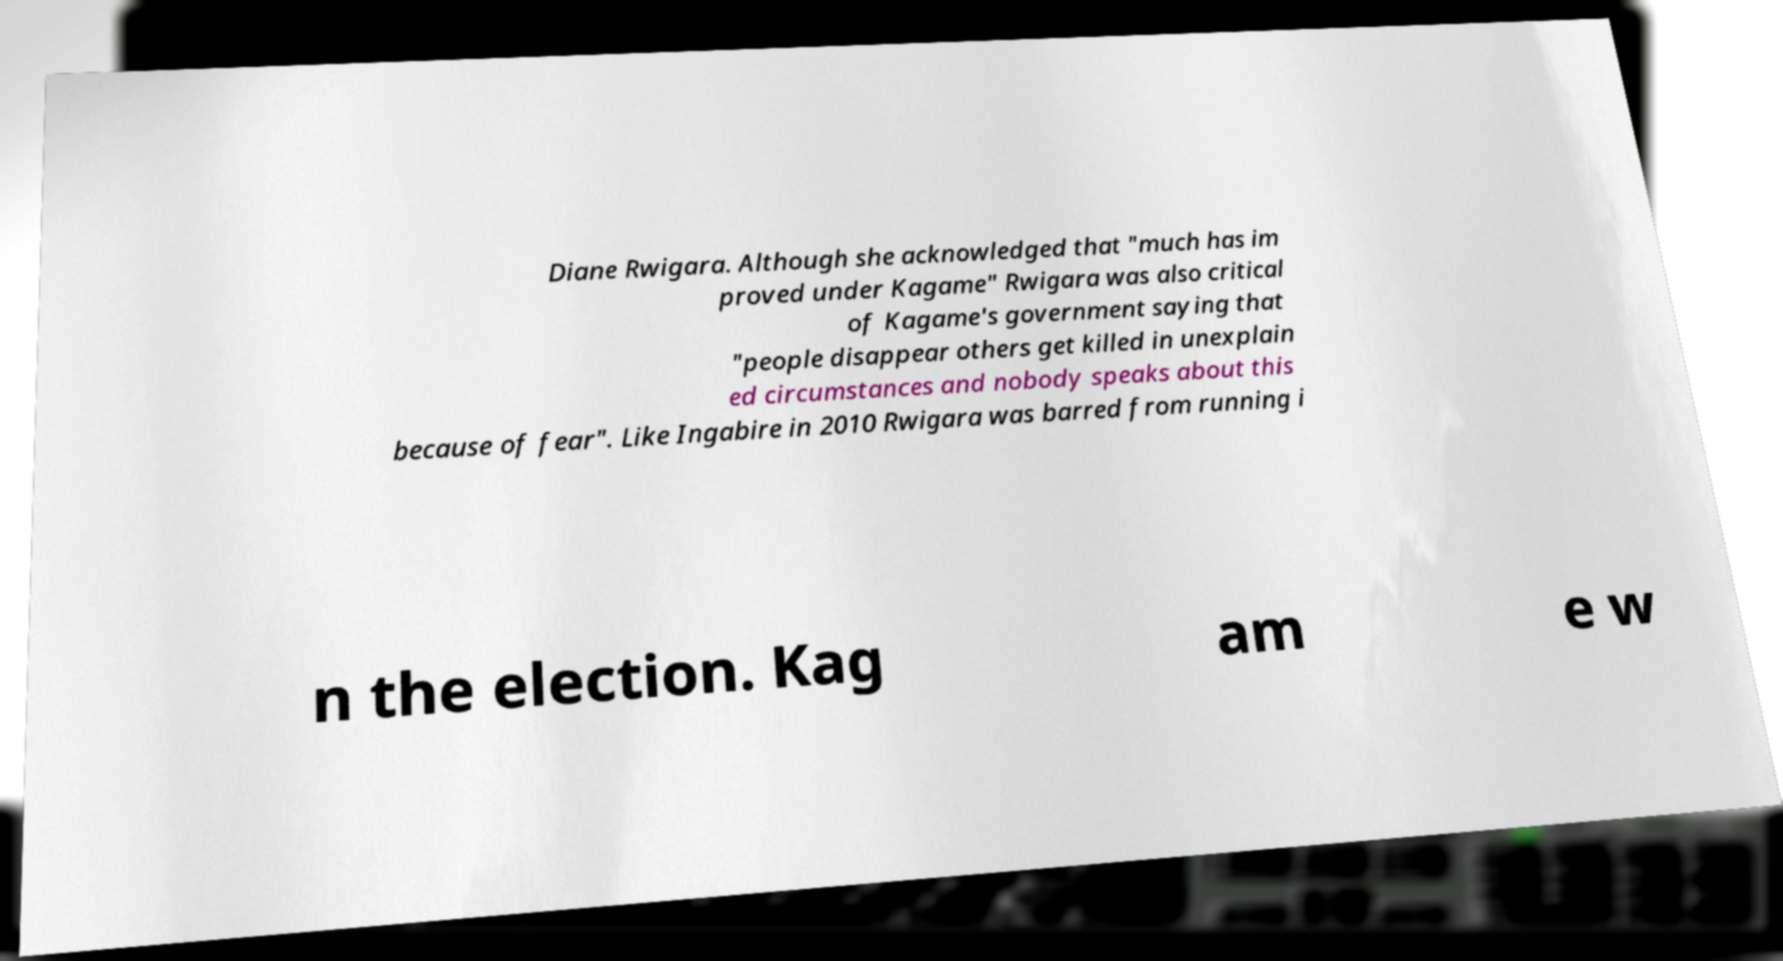Could you assist in decoding the text presented in this image and type it out clearly? Diane Rwigara. Although she acknowledged that "much has im proved under Kagame" Rwigara was also critical of Kagame's government saying that "people disappear others get killed in unexplain ed circumstances and nobody speaks about this because of fear". Like Ingabire in 2010 Rwigara was barred from running i n the election. Kag am e w 